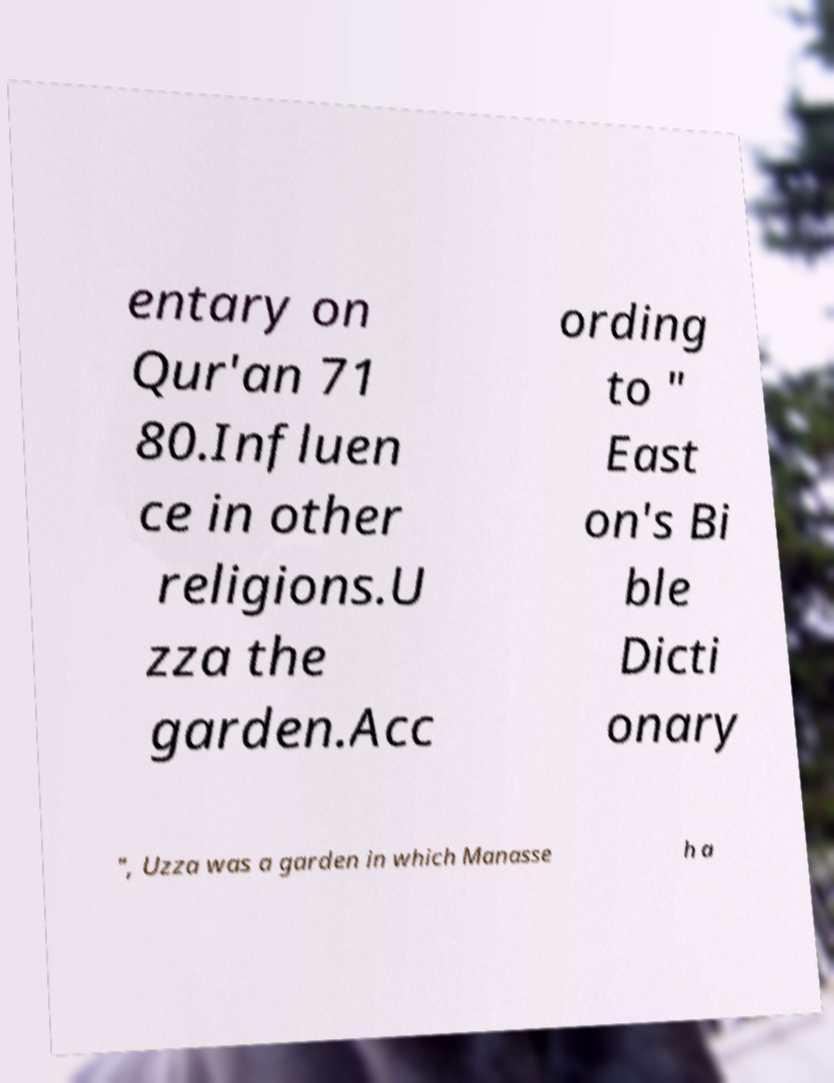Please read and relay the text visible in this image. What does it say? entary on Qur'an 71 80.Influen ce in other religions.U zza the garden.Acc ording to " East on's Bi ble Dicti onary ", Uzza was a garden in which Manasse h a 